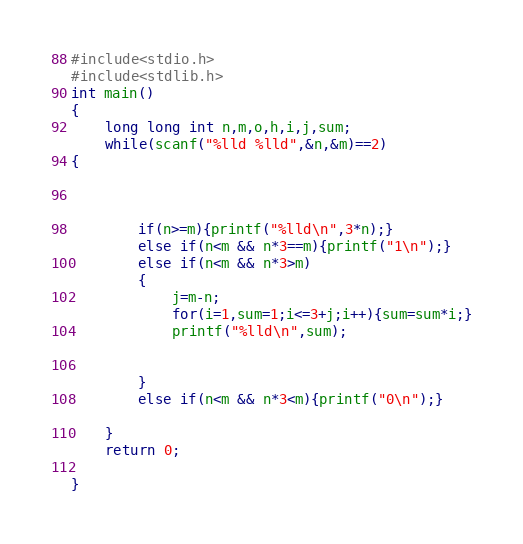Convert code to text. <code><loc_0><loc_0><loc_500><loc_500><_C_>#include<stdio.h>
#include<stdlib.h>
int main()
{
    long long int n,m,o,h,i,j,sum;
    while(scanf("%lld %lld",&n,&m)==2)
{



        if(n>=m){printf("%lld\n",3*n);}
        else if(n<m && n*3==m){printf("1\n");}
        else if(n<m && n*3>m)
        {
            j=m-n;
            for(i=1,sum=1;i<=3+j;i++){sum=sum*i;}
            printf("%lld\n",sum);


        }
        else if(n<m && n*3<m){printf("0\n");}

    }
    return 0;

}
</code> 